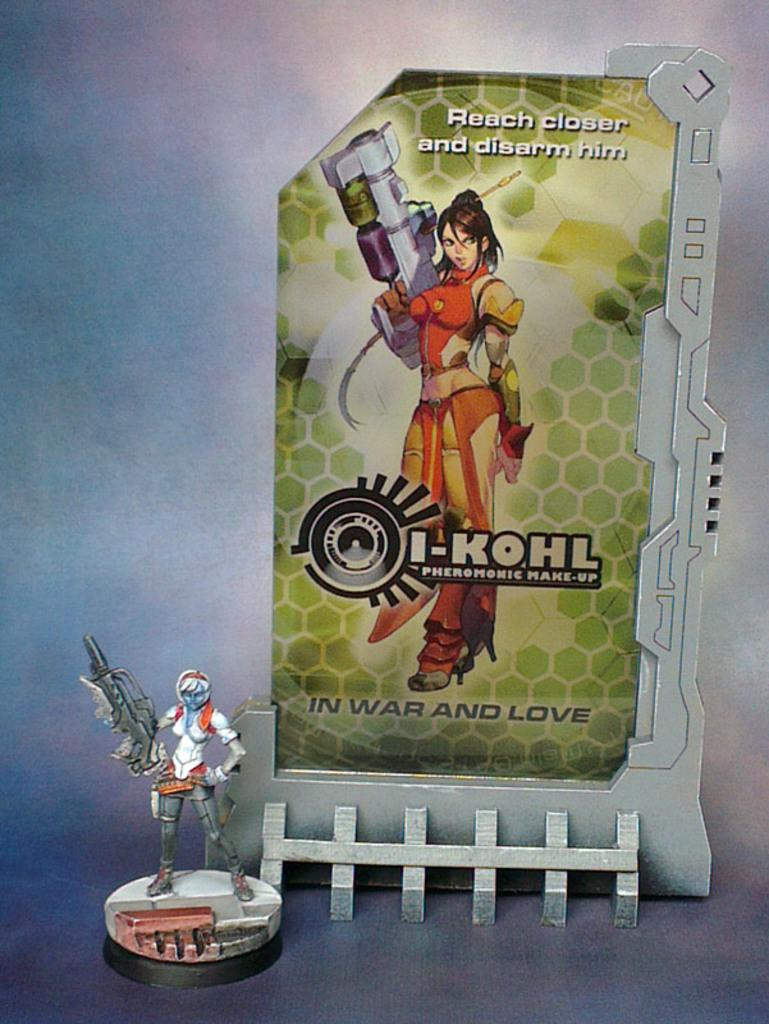<image>
Relay a brief, clear account of the picture shown. a sign behind a figure, that says 'i-kohl pheromic make-up' 